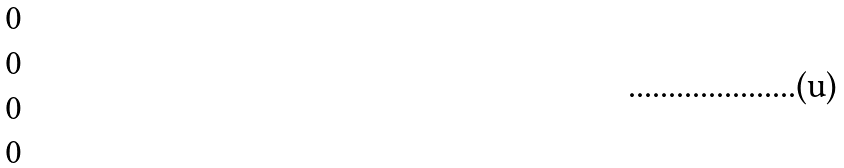<formula> <loc_0><loc_0><loc_500><loc_500>\begin{matrix} 0 \\ 0 \\ 0 \\ 0 \end{matrix}</formula> 